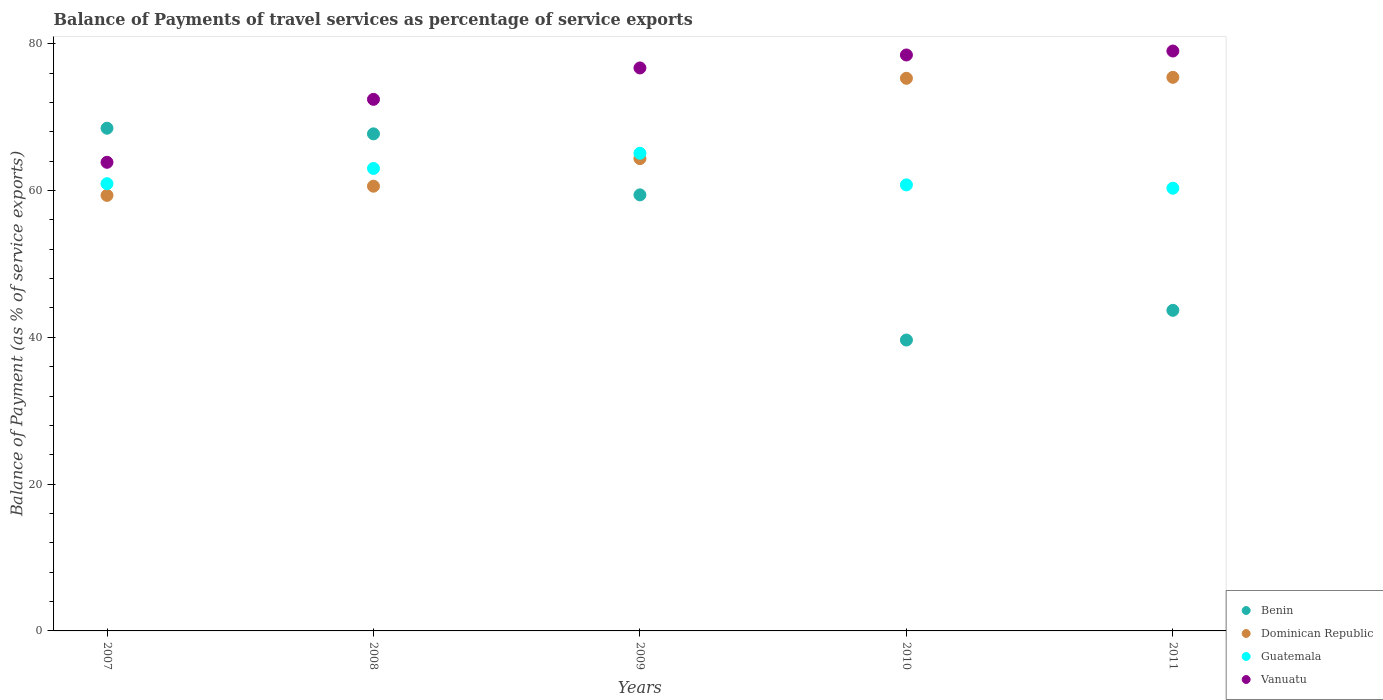How many different coloured dotlines are there?
Provide a succinct answer. 4. What is the balance of payments of travel services in Guatemala in 2007?
Offer a very short reply. 60.92. Across all years, what is the maximum balance of payments of travel services in Benin?
Provide a short and direct response. 68.48. Across all years, what is the minimum balance of payments of travel services in Benin?
Your response must be concise. 39.63. In which year was the balance of payments of travel services in Guatemala minimum?
Keep it short and to the point. 2011. What is the total balance of payments of travel services in Vanuatu in the graph?
Give a very brief answer. 370.39. What is the difference between the balance of payments of travel services in Vanuatu in 2008 and that in 2009?
Your response must be concise. -4.28. What is the difference between the balance of payments of travel services in Vanuatu in 2010 and the balance of payments of travel services in Dominican Republic in 2008?
Ensure brevity in your answer.  17.87. What is the average balance of payments of travel services in Dominican Republic per year?
Your answer should be very brief. 66.99. In the year 2011, what is the difference between the balance of payments of travel services in Benin and balance of payments of travel services in Dominican Republic?
Your response must be concise. -31.74. In how many years, is the balance of payments of travel services in Dominican Republic greater than 52 %?
Your answer should be compact. 5. What is the ratio of the balance of payments of travel services in Guatemala in 2007 to that in 2009?
Your answer should be very brief. 0.94. Is the balance of payments of travel services in Vanuatu in 2008 less than that in 2009?
Provide a succinct answer. Yes. What is the difference between the highest and the second highest balance of payments of travel services in Dominican Republic?
Your answer should be very brief. 0.13. What is the difference between the highest and the lowest balance of payments of travel services in Vanuatu?
Make the answer very short. 15.16. Is it the case that in every year, the sum of the balance of payments of travel services in Benin and balance of payments of travel services in Vanuatu  is greater than the balance of payments of travel services in Dominican Republic?
Ensure brevity in your answer.  Yes. How many dotlines are there?
Offer a very short reply. 4. How many years are there in the graph?
Keep it short and to the point. 5. Are the values on the major ticks of Y-axis written in scientific E-notation?
Keep it short and to the point. No. Does the graph contain any zero values?
Your answer should be very brief. No. Does the graph contain grids?
Offer a very short reply. No. How are the legend labels stacked?
Your response must be concise. Vertical. What is the title of the graph?
Offer a terse response. Balance of Payments of travel services as percentage of service exports. Does "Poland" appear as one of the legend labels in the graph?
Offer a terse response. No. What is the label or title of the Y-axis?
Your answer should be very brief. Balance of Payment (as % of service exports). What is the Balance of Payment (as % of service exports) in Benin in 2007?
Give a very brief answer. 68.48. What is the Balance of Payment (as % of service exports) of Dominican Republic in 2007?
Keep it short and to the point. 59.33. What is the Balance of Payment (as % of service exports) in Guatemala in 2007?
Your answer should be compact. 60.92. What is the Balance of Payment (as % of service exports) in Vanuatu in 2007?
Ensure brevity in your answer.  63.84. What is the Balance of Payment (as % of service exports) of Benin in 2008?
Provide a short and direct response. 67.71. What is the Balance of Payment (as % of service exports) in Dominican Republic in 2008?
Your response must be concise. 60.58. What is the Balance of Payment (as % of service exports) in Guatemala in 2008?
Keep it short and to the point. 63. What is the Balance of Payment (as % of service exports) of Vanuatu in 2008?
Your answer should be very brief. 72.41. What is the Balance of Payment (as % of service exports) in Benin in 2009?
Keep it short and to the point. 59.4. What is the Balance of Payment (as % of service exports) in Dominican Republic in 2009?
Your response must be concise. 64.34. What is the Balance of Payment (as % of service exports) in Guatemala in 2009?
Your answer should be compact. 65.07. What is the Balance of Payment (as % of service exports) in Vanuatu in 2009?
Offer a very short reply. 76.69. What is the Balance of Payment (as % of service exports) in Benin in 2010?
Give a very brief answer. 39.63. What is the Balance of Payment (as % of service exports) of Dominican Republic in 2010?
Offer a terse response. 75.28. What is the Balance of Payment (as % of service exports) of Guatemala in 2010?
Provide a short and direct response. 60.76. What is the Balance of Payment (as % of service exports) in Vanuatu in 2010?
Provide a succinct answer. 78.46. What is the Balance of Payment (as % of service exports) of Benin in 2011?
Offer a very short reply. 43.67. What is the Balance of Payment (as % of service exports) in Dominican Republic in 2011?
Ensure brevity in your answer.  75.41. What is the Balance of Payment (as % of service exports) of Guatemala in 2011?
Provide a succinct answer. 60.31. What is the Balance of Payment (as % of service exports) in Vanuatu in 2011?
Offer a very short reply. 78.99. Across all years, what is the maximum Balance of Payment (as % of service exports) of Benin?
Make the answer very short. 68.48. Across all years, what is the maximum Balance of Payment (as % of service exports) in Dominican Republic?
Give a very brief answer. 75.41. Across all years, what is the maximum Balance of Payment (as % of service exports) in Guatemala?
Provide a succinct answer. 65.07. Across all years, what is the maximum Balance of Payment (as % of service exports) of Vanuatu?
Offer a terse response. 78.99. Across all years, what is the minimum Balance of Payment (as % of service exports) in Benin?
Make the answer very short. 39.63. Across all years, what is the minimum Balance of Payment (as % of service exports) of Dominican Republic?
Your response must be concise. 59.33. Across all years, what is the minimum Balance of Payment (as % of service exports) in Guatemala?
Your response must be concise. 60.31. Across all years, what is the minimum Balance of Payment (as % of service exports) in Vanuatu?
Ensure brevity in your answer.  63.84. What is the total Balance of Payment (as % of service exports) of Benin in the graph?
Give a very brief answer. 278.89. What is the total Balance of Payment (as % of service exports) in Dominican Republic in the graph?
Offer a terse response. 334.94. What is the total Balance of Payment (as % of service exports) of Guatemala in the graph?
Keep it short and to the point. 310.06. What is the total Balance of Payment (as % of service exports) in Vanuatu in the graph?
Your answer should be compact. 370.39. What is the difference between the Balance of Payment (as % of service exports) of Benin in 2007 and that in 2008?
Ensure brevity in your answer.  0.77. What is the difference between the Balance of Payment (as % of service exports) of Dominican Republic in 2007 and that in 2008?
Make the answer very short. -1.25. What is the difference between the Balance of Payment (as % of service exports) in Guatemala in 2007 and that in 2008?
Provide a short and direct response. -2.08. What is the difference between the Balance of Payment (as % of service exports) of Vanuatu in 2007 and that in 2008?
Offer a very short reply. -8.58. What is the difference between the Balance of Payment (as % of service exports) of Benin in 2007 and that in 2009?
Provide a succinct answer. 9.08. What is the difference between the Balance of Payment (as % of service exports) in Dominican Republic in 2007 and that in 2009?
Your answer should be compact. -5.01. What is the difference between the Balance of Payment (as % of service exports) of Guatemala in 2007 and that in 2009?
Give a very brief answer. -4.14. What is the difference between the Balance of Payment (as % of service exports) of Vanuatu in 2007 and that in 2009?
Offer a terse response. -12.86. What is the difference between the Balance of Payment (as % of service exports) in Benin in 2007 and that in 2010?
Provide a succinct answer. 28.85. What is the difference between the Balance of Payment (as % of service exports) in Dominican Republic in 2007 and that in 2010?
Give a very brief answer. -15.95. What is the difference between the Balance of Payment (as % of service exports) of Guatemala in 2007 and that in 2010?
Provide a short and direct response. 0.16. What is the difference between the Balance of Payment (as % of service exports) of Vanuatu in 2007 and that in 2010?
Make the answer very short. -14.62. What is the difference between the Balance of Payment (as % of service exports) of Benin in 2007 and that in 2011?
Your response must be concise. 24.81. What is the difference between the Balance of Payment (as % of service exports) of Dominican Republic in 2007 and that in 2011?
Provide a succinct answer. -16.08. What is the difference between the Balance of Payment (as % of service exports) of Guatemala in 2007 and that in 2011?
Provide a short and direct response. 0.62. What is the difference between the Balance of Payment (as % of service exports) of Vanuatu in 2007 and that in 2011?
Keep it short and to the point. -15.16. What is the difference between the Balance of Payment (as % of service exports) in Benin in 2008 and that in 2009?
Keep it short and to the point. 8.31. What is the difference between the Balance of Payment (as % of service exports) of Dominican Republic in 2008 and that in 2009?
Keep it short and to the point. -3.76. What is the difference between the Balance of Payment (as % of service exports) of Guatemala in 2008 and that in 2009?
Your answer should be compact. -2.07. What is the difference between the Balance of Payment (as % of service exports) in Vanuatu in 2008 and that in 2009?
Offer a very short reply. -4.28. What is the difference between the Balance of Payment (as % of service exports) in Benin in 2008 and that in 2010?
Your response must be concise. 28.08. What is the difference between the Balance of Payment (as % of service exports) in Dominican Republic in 2008 and that in 2010?
Offer a very short reply. -14.7. What is the difference between the Balance of Payment (as % of service exports) of Guatemala in 2008 and that in 2010?
Your response must be concise. 2.24. What is the difference between the Balance of Payment (as % of service exports) of Vanuatu in 2008 and that in 2010?
Your answer should be very brief. -6.04. What is the difference between the Balance of Payment (as % of service exports) in Benin in 2008 and that in 2011?
Provide a short and direct response. 24.04. What is the difference between the Balance of Payment (as % of service exports) of Dominican Republic in 2008 and that in 2011?
Your answer should be very brief. -14.83. What is the difference between the Balance of Payment (as % of service exports) in Guatemala in 2008 and that in 2011?
Give a very brief answer. 2.69. What is the difference between the Balance of Payment (as % of service exports) in Vanuatu in 2008 and that in 2011?
Offer a terse response. -6.58. What is the difference between the Balance of Payment (as % of service exports) of Benin in 2009 and that in 2010?
Offer a terse response. 19.77. What is the difference between the Balance of Payment (as % of service exports) of Dominican Republic in 2009 and that in 2010?
Your answer should be compact. -10.94. What is the difference between the Balance of Payment (as % of service exports) in Guatemala in 2009 and that in 2010?
Keep it short and to the point. 4.31. What is the difference between the Balance of Payment (as % of service exports) of Vanuatu in 2009 and that in 2010?
Your response must be concise. -1.77. What is the difference between the Balance of Payment (as % of service exports) of Benin in 2009 and that in 2011?
Make the answer very short. 15.73. What is the difference between the Balance of Payment (as % of service exports) of Dominican Republic in 2009 and that in 2011?
Give a very brief answer. -11.07. What is the difference between the Balance of Payment (as % of service exports) in Guatemala in 2009 and that in 2011?
Your response must be concise. 4.76. What is the difference between the Balance of Payment (as % of service exports) in Vanuatu in 2009 and that in 2011?
Offer a very short reply. -2.3. What is the difference between the Balance of Payment (as % of service exports) of Benin in 2010 and that in 2011?
Keep it short and to the point. -4.04. What is the difference between the Balance of Payment (as % of service exports) in Dominican Republic in 2010 and that in 2011?
Provide a succinct answer. -0.13. What is the difference between the Balance of Payment (as % of service exports) of Guatemala in 2010 and that in 2011?
Your answer should be compact. 0.46. What is the difference between the Balance of Payment (as % of service exports) in Vanuatu in 2010 and that in 2011?
Offer a very short reply. -0.54. What is the difference between the Balance of Payment (as % of service exports) in Benin in 2007 and the Balance of Payment (as % of service exports) in Dominican Republic in 2008?
Provide a short and direct response. 7.9. What is the difference between the Balance of Payment (as % of service exports) of Benin in 2007 and the Balance of Payment (as % of service exports) of Guatemala in 2008?
Provide a short and direct response. 5.48. What is the difference between the Balance of Payment (as % of service exports) in Benin in 2007 and the Balance of Payment (as % of service exports) in Vanuatu in 2008?
Provide a succinct answer. -3.93. What is the difference between the Balance of Payment (as % of service exports) of Dominican Republic in 2007 and the Balance of Payment (as % of service exports) of Guatemala in 2008?
Your response must be concise. -3.67. What is the difference between the Balance of Payment (as % of service exports) in Dominican Republic in 2007 and the Balance of Payment (as % of service exports) in Vanuatu in 2008?
Offer a terse response. -13.08. What is the difference between the Balance of Payment (as % of service exports) in Guatemala in 2007 and the Balance of Payment (as % of service exports) in Vanuatu in 2008?
Keep it short and to the point. -11.49. What is the difference between the Balance of Payment (as % of service exports) of Benin in 2007 and the Balance of Payment (as % of service exports) of Dominican Republic in 2009?
Offer a very short reply. 4.14. What is the difference between the Balance of Payment (as % of service exports) in Benin in 2007 and the Balance of Payment (as % of service exports) in Guatemala in 2009?
Provide a short and direct response. 3.41. What is the difference between the Balance of Payment (as % of service exports) in Benin in 2007 and the Balance of Payment (as % of service exports) in Vanuatu in 2009?
Provide a succinct answer. -8.21. What is the difference between the Balance of Payment (as % of service exports) in Dominican Republic in 2007 and the Balance of Payment (as % of service exports) in Guatemala in 2009?
Provide a short and direct response. -5.74. What is the difference between the Balance of Payment (as % of service exports) in Dominican Republic in 2007 and the Balance of Payment (as % of service exports) in Vanuatu in 2009?
Provide a succinct answer. -17.36. What is the difference between the Balance of Payment (as % of service exports) in Guatemala in 2007 and the Balance of Payment (as % of service exports) in Vanuatu in 2009?
Make the answer very short. -15.77. What is the difference between the Balance of Payment (as % of service exports) of Benin in 2007 and the Balance of Payment (as % of service exports) of Dominican Republic in 2010?
Give a very brief answer. -6.8. What is the difference between the Balance of Payment (as % of service exports) of Benin in 2007 and the Balance of Payment (as % of service exports) of Guatemala in 2010?
Give a very brief answer. 7.72. What is the difference between the Balance of Payment (as % of service exports) of Benin in 2007 and the Balance of Payment (as % of service exports) of Vanuatu in 2010?
Offer a very short reply. -9.98. What is the difference between the Balance of Payment (as % of service exports) in Dominican Republic in 2007 and the Balance of Payment (as % of service exports) in Guatemala in 2010?
Your answer should be compact. -1.43. What is the difference between the Balance of Payment (as % of service exports) of Dominican Republic in 2007 and the Balance of Payment (as % of service exports) of Vanuatu in 2010?
Ensure brevity in your answer.  -19.13. What is the difference between the Balance of Payment (as % of service exports) of Guatemala in 2007 and the Balance of Payment (as % of service exports) of Vanuatu in 2010?
Ensure brevity in your answer.  -17.53. What is the difference between the Balance of Payment (as % of service exports) in Benin in 2007 and the Balance of Payment (as % of service exports) in Dominican Republic in 2011?
Your answer should be very brief. -6.93. What is the difference between the Balance of Payment (as % of service exports) of Benin in 2007 and the Balance of Payment (as % of service exports) of Guatemala in 2011?
Make the answer very short. 8.17. What is the difference between the Balance of Payment (as % of service exports) of Benin in 2007 and the Balance of Payment (as % of service exports) of Vanuatu in 2011?
Provide a short and direct response. -10.52. What is the difference between the Balance of Payment (as % of service exports) of Dominican Republic in 2007 and the Balance of Payment (as % of service exports) of Guatemala in 2011?
Provide a short and direct response. -0.98. What is the difference between the Balance of Payment (as % of service exports) in Dominican Republic in 2007 and the Balance of Payment (as % of service exports) in Vanuatu in 2011?
Your answer should be compact. -19.67. What is the difference between the Balance of Payment (as % of service exports) in Guatemala in 2007 and the Balance of Payment (as % of service exports) in Vanuatu in 2011?
Ensure brevity in your answer.  -18.07. What is the difference between the Balance of Payment (as % of service exports) of Benin in 2008 and the Balance of Payment (as % of service exports) of Dominican Republic in 2009?
Provide a succinct answer. 3.37. What is the difference between the Balance of Payment (as % of service exports) in Benin in 2008 and the Balance of Payment (as % of service exports) in Guatemala in 2009?
Your response must be concise. 2.64. What is the difference between the Balance of Payment (as % of service exports) of Benin in 2008 and the Balance of Payment (as % of service exports) of Vanuatu in 2009?
Make the answer very short. -8.98. What is the difference between the Balance of Payment (as % of service exports) of Dominican Republic in 2008 and the Balance of Payment (as % of service exports) of Guatemala in 2009?
Provide a succinct answer. -4.49. What is the difference between the Balance of Payment (as % of service exports) of Dominican Republic in 2008 and the Balance of Payment (as % of service exports) of Vanuatu in 2009?
Provide a short and direct response. -16.11. What is the difference between the Balance of Payment (as % of service exports) in Guatemala in 2008 and the Balance of Payment (as % of service exports) in Vanuatu in 2009?
Offer a very short reply. -13.69. What is the difference between the Balance of Payment (as % of service exports) in Benin in 2008 and the Balance of Payment (as % of service exports) in Dominican Republic in 2010?
Your answer should be compact. -7.57. What is the difference between the Balance of Payment (as % of service exports) of Benin in 2008 and the Balance of Payment (as % of service exports) of Guatemala in 2010?
Your answer should be very brief. 6.95. What is the difference between the Balance of Payment (as % of service exports) in Benin in 2008 and the Balance of Payment (as % of service exports) in Vanuatu in 2010?
Offer a terse response. -10.75. What is the difference between the Balance of Payment (as % of service exports) of Dominican Republic in 2008 and the Balance of Payment (as % of service exports) of Guatemala in 2010?
Provide a short and direct response. -0.18. What is the difference between the Balance of Payment (as % of service exports) in Dominican Republic in 2008 and the Balance of Payment (as % of service exports) in Vanuatu in 2010?
Your response must be concise. -17.87. What is the difference between the Balance of Payment (as % of service exports) of Guatemala in 2008 and the Balance of Payment (as % of service exports) of Vanuatu in 2010?
Offer a terse response. -15.46. What is the difference between the Balance of Payment (as % of service exports) in Benin in 2008 and the Balance of Payment (as % of service exports) in Dominican Republic in 2011?
Provide a succinct answer. -7.7. What is the difference between the Balance of Payment (as % of service exports) in Benin in 2008 and the Balance of Payment (as % of service exports) in Guatemala in 2011?
Your response must be concise. 7.41. What is the difference between the Balance of Payment (as % of service exports) in Benin in 2008 and the Balance of Payment (as % of service exports) in Vanuatu in 2011?
Keep it short and to the point. -11.28. What is the difference between the Balance of Payment (as % of service exports) of Dominican Republic in 2008 and the Balance of Payment (as % of service exports) of Guatemala in 2011?
Give a very brief answer. 0.28. What is the difference between the Balance of Payment (as % of service exports) of Dominican Republic in 2008 and the Balance of Payment (as % of service exports) of Vanuatu in 2011?
Your answer should be compact. -18.41. What is the difference between the Balance of Payment (as % of service exports) of Guatemala in 2008 and the Balance of Payment (as % of service exports) of Vanuatu in 2011?
Ensure brevity in your answer.  -15.99. What is the difference between the Balance of Payment (as % of service exports) in Benin in 2009 and the Balance of Payment (as % of service exports) in Dominican Republic in 2010?
Your answer should be very brief. -15.88. What is the difference between the Balance of Payment (as % of service exports) in Benin in 2009 and the Balance of Payment (as % of service exports) in Guatemala in 2010?
Offer a very short reply. -1.36. What is the difference between the Balance of Payment (as % of service exports) in Benin in 2009 and the Balance of Payment (as % of service exports) in Vanuatu in 2010?
Give a very brief answer. -19.06. What is the difference between the Balance of Payment (as % of service exports) in Dominican Republic in 2009 and the Balance of Payment (as % of service exports) in Guatemala in 2010?
Ensure brevity in your answer.  3.58. What is the difference between the Balance of Payment (as % of service exports) of Dominican Republic in 2009 and the Balance of Payment (as % of service exports) of Vanuatu in 2010?
Offer a terse response. -14.12. What is the difference between the Balance of Payment (as % of service exports) in Guatemala in 2009 and the Balance of Payment (as % of service exports) in Vanuatu in 2010?
Your answer should be compact. -13.39. What is the difference between the Balance of Payment (as % of service exports) of Benin in 2009 and the Balance of Payment (as % of service exports) of Dominican Republic in 2011?
Offer a terse response. -16.01. What is the difference between the Balance of Payment (as % of service exports) of Benin in 2009 and the Balance of Payment (as % of service exports) of Guatemala in 2011?
Offer a terse response. -0.91. What is the difference between the Balance of Payment (as % of service exports) of Benin in 2009 and the Balance of Payment (as % of service exports) of Vanuatu in 2011?
Ensure brevity in your answer.  -19.59. What is the difference between the Balance of Payment (as % of service exports) of Dominican Republic in 2009 and the Balance of Payment (as % of service exports) of Guatemala in 2011?
Make the answer very short. 4.04. What is the difference between the Balance of Payment (as % of service exports) in Dominican Republic in 2009 and the Balance of Payment (as % of service exports) in Vanuatu in 2011?
Give a very brief answer. -14.65. What is the difference between the Balance of Payment (as % of service exports) in Guatemala in 2009 and the Balance of Payment (as % of service exports) in Vanuatu in 2011?
Keep it short and to the point. -13.93. What is the difference between the Balance of Payment (as % of service exports) in Benin in 2010 and the Balance of Payment (as % of service exports) in Dominican Republic in 2011?
Give a very brief answer. -35.78. What is the difference between the Balance of Payment (as % of service exports) in Benin in 2010 and the Balance of Payment (as % of service exports) in Guatemala in 2011?
Offer a very short reply. -20.68. What is the difference between the Balance of Payment (as % of service exports) of Benin in 2010 and the Balance of Payment (as % of service exports) of Vanuatu in 2011?
Ensure brevity in your answer.  -39.37. What is the difference between the Balance of Payment (as % of service exports) of Dominican Republic in 2010 and the Balance of Payment (as % of service exports) of Guatemala in 2011?
Make the answer very short. 14.98. What is the difference between the Balance of Payment (as % of service exports) of Dominican Republic in 2010 and the Balance of Payment (as % of service exports) of Vanuatu in 2011?
Ensure brevity in your answer.  -3.71. What is the difference between the Balance of Payment (as % of service exports) of Guatemala in 2010 and the Balance of Payment (as % of service exports) of Vanuatu in 2011?
Provide a succinct answer. -18.23. What is the average Balance of Payment (as % of service exports) of Benin per year?
Make the answer very short. 55.78. What is the average Balance of Payment (as % of service exports) of Dominican Republic per year?
Offer a very short reply. 66.99. What is the average Balance of Payment (as % of service exports) of Guatemala per year?
Make the answer very short. 62.01. What is the average Balance of Payment (as % of service exports) of Vanuatu per year?
Keep it short and to the point. 74.08. In the year 2007, what is the difference between the Balance of Payment (as % of service exports) of Benin and Balance of Payment (as % of service exports) of Dominican Republic?
Offer a very short reply. 9.15. In the year 2007, what is the difference between the Balance of Payment (as % of service exports) of Benin and Balance of Payment (as % of service exports) of Guatemala?
Your answer should be compact. 7.56. In the year 2007, what is the difference between the Balance of Payment (as % of service exports) of Benin and Balance of Payment (as % of service exports) of Vanuatu?
Your answer should be compact. 4.64. In the year 2007, what is the difference between the Balance of Payment (as % of service exports) in Dominican Republic and Balance of Payment (as % of service exports) in Guatemala?
Your answer should be very brief. -1.59. In the year 2007, what is the difference between the Balance of Payment (as % of service exports) of Dominican Republic and Balance of Payment (as % of service exports) of Vanuatu?
Offer a very short reply. -4.51. In the year 2007, what is the difference between the Balance of Payment (as % of service exports) in Guatemala and Balance of Payment (as % of service exports) in Vanuatu?
Make the answer very short. -2.91. In the year 2008, what is the difference between the Balance of Payment (as % of service exports) in Benin and Balance of Payment (as % of service exports) in Dominican Republic?
Make the answer very short. 7.13. In the year 2008, what is the difference between the Balance of Payment (as % of service exports) in Benin and Balance of Payment (as % of service exports) in Guatemala?
Offer a very short reply. 4.71. In the year 2008, what is the difference between the Balance of Payment (as % of service exports) of Benin and Balance of Payment (as % of service exports) of Vanuatu?
Give a very brief answer. -4.7. In the year 2008, what is the difference between the Balance of Payment (as % of service exports) of Dominican Republic and Balance of Payment (as % of service exports) of Guatemala?
Offer a very short reply. -2.42. In the year 2008, what is the difference between the Balance of Payment (as % of service exports) of Dominican Republic and Balance of Payment (as % of service exports) of Vanuatu?
Offer a terse response. -11.83. In the year 2008, what is the difference between the Balance of Payment (as % of service exports) in Guatemala and Balance of Payment (as % of service exports) in Vanuatu?
Offer a terse response. -9.41. In the year 2009, what is the difference between the Balance of Payment (as % of service exports) in Benin and Balance of Payment (as % of service exports) in Dominican Republic?
Provide a short and direct response. -4.94. In the year 2009, what is the difference between the Balance of Payment (as % of service exports) of Benin and Balance of Payment (as % of service exports) of Guatemala?
Offer a terse response. -5.67. In the year 2009, what is the difference between the Balance of Payment (as % of service exports) of Benin and Balance of Payment (as % of service exports) of Vanuatu?
Offer a very short reply. -17.29. In the year 2009, what is the difference between the Balance of Payment (as % of service exports) in Dominican Republic and Balance of Payment (as % of service exports) in Guatemala?
Make the answer very short. -0.73. In the year 2009, what is the difference between the Balance of Payment (as % of service exports) in Dominican Republic and Balance of Payment (as % of service exports) in Vanuatu?
Your response must be concise. -12.35. In the year 2009, what is the difference between the Balance of Payment (as % of service exports) in Guatemala and Balance of Payment (as % of service exports) in Vanuatu?
Provide a succinct answer. -11.62. In the year 2010, what is the difference between the Balance of Payment (as % of service exports) of Benin and Balance of Payment (as % of service exports) of Dominican Republic?
Provide a short and direct response. -35.65. In the year 2010, what is the difference between the Balance of Payment (as % of service exports) in Benin and Balance of Payment (as % of service exports) in Guatemala?
Give a very brief answer. -21.13. In the year 2010, what is the difference between the Balance of Payment (as % of service exports) of Benin and Balance of Payment (as % of service exports) of Vanuatu?
Make the answer very short. -38.83. In the year 2010, what is the difference between the Balance of Payment (as % of service exports) in Dominican Republic and Balance of Payment (as % of service exports) in Guatemala?
Ensure brevity in your answer.  14.52. In the year 2010, what is the difference between the Balance of Payment (as % of service exports) in Dominican Republic and Balance of Payment (as % of service exports) in Vanuatu?
Offer a very short reply. -3.18. In the year 2010, what is the difference between the Balance of Payment (as % of service exports) in Guatemala and Balance of Payment (as % of service exports) in Vanuatu?
Your answer should be compact. -17.7. In the year 2011, what is the difference between the Balance of Payment (as % of service exports) in Benin and Balance of Payment (as % of service exports) in Dominican Republic?
Keep it short and to the point. -31.74. In the year 2011, what is the difference between the Balance of Payment (as % of service exports) in Benin and Balance of Payment (as % of service exports) in Guatemala?
Provide a short and direct response. -16.63. In the year 2011, what is the difference between the Balance of Payment (as % of service exports) of Benin and Balance of Payment (as % of service exports) of Vanuatu?
Your answer should be very brief. -35.32. In the year 2011, what is the difference between the Balance of Payment (as % of service exports) in Dominican Republic and Balance of Payment (as % of service exports) in Guatemala?
Provide a succinct answer. 15.11. In the year 2011, what is the difference between the Balance of Payment (as % of service exports) of Dominican Republic and Balance of Payment (as % of service exports) of Vanuatu?
Make the answer very short. -3.58. In the year 2011, what is the difference between the Balance of Payment (as % of service exports) in Guatemala and Balance of Payment (as % of service exports) in Vanuatu?
Give a very brief answer. -18.69. What is the ratio of the Balance of Payment (as % of service exports) of Benin in 2007 to that in 2008?
Your answer should be compact. 1.01. What is the ratio of the Balance of Payment (as % of service exports) in Dominican Republic in 2007 to that in 2008?
Your answer should be very brief. 0.98. What is the ratio of the Balance of Payment (as % of service exports) in Vanuatu in 2007 to that in 2008?
Your answer should be compact. 0.88. What is the ratio of the Balance of Payment (as % of service exports) in Benin in 2007 to that in 2009?
Keep it short and to the point. 1.15. What is the ratio of the Balance of Payment (as % of service exports) of Dominican Republic in 2007 to that in 2009?
Make the answer very short. 0.92. What is the ratio of the Balance of Payment (as % of service exports) of Guatemala in 2007 to that in 2009?
Your answer should be very brief. 0.94. What is the ratio of the Balance of Payment (as % of service exports) in Vanuatu in 2007 to that in 2009?
Ensure brevity in your answer.  0.83. What is the ratio of the Balance of Payment (as % of service exports) in Benin in 2007 to that in 2010?
Your answer should be compact. 1.73. What is the ratio of the Balance of Payment (as % of service exports) in Dominican Republic in 2007 to that in 2010?
Offer a very short reply. 0.79. What is the ratio of the Balance of Payment (as % of service exports) in Guatemala in 2007 to that in 2010?
Make the answer very short. 1. What is the ratio of the Balance of Payment (as % of service exports) of Vanuatu in 2007 to that in 2010?
Provide a succinct answer. 0.81. What is the ratio of the Balance of Payment (as % of service exports) in Benin in 2007 to that in 2011?
Give a very brief answer. 1.57. What is the ratio of the Balance of Payment (as % of service exports) of Dominican Republic in 2007 to that in 2011?
Ensure brevity in your answer.  0.79. What is the ratio of the Balance of Payment (as % of service exports) in Guatemala in 2007 to that in 2011?
Provide a short and direct response. 1.01. What is the ratio of the Balance of Payment (as % of service exports) of Vanuatu in 2007 to that in 2011?
Provide a succinct answer. 0.81. What is the ratio of the Balance of Payment (as % of service exports) of Benin in 2008 to that in 2009?
Make the answer very short. 1.14. What is the ratio of the Balance of Payment (as % of service exports) of Dominican Republic in 2008 to that in 2009?
Ensure brevity in your answer.  0.94. What is the ratio of the Balance of Payment (as % of service exports) of Guatemala in 2008 to that in 2009?
Your answer should be very brief. 0.97. What is the ratio of the Balance of Payment (as % of service exports) in Vanuatu in 2008 to that in 2009?
Ensure brevity in your answer.  0.94. What is the ratio of the Balance of Payment (as % of service exports) of Benin in 2008 to that in 2010?
Give a very brief answer. 1.71. What is the ratio of the Balance of Payment (as % of service exports) in Dominican Republic in 2008 to that in 2010?
Offer a very short reply. 0.8. What is the ratio of the Balance of Payment (as % of service exports) in Guatemala in 2008 to that in 2010?
Your answer should be compact. 1.04. What is the ratio of the Balance of Payment (as % of service exports) of Vanuatu in 2008 to that in 2010?
Give a very brief answer. 0.92. What is the ratio of the Balance of Payment (as % of service exports) of Benin in 2008 to that in 2011?
Make the answer very short. 1.55. What is the ratio of the Balance of Payment (as % of service exports) of Dominican Republic in 2008 to that in 2011?
Make the answer very short. 0.8. What is the ratio of the Balance of Payment (as % of service exports) of Guatemala in 2008 to that in 2011?
Keep it short and to the point. 1.04. What is the ratio of the Balance of Payment (as % of service exports) of Benin in 2009 to that in 2010?
Provide a short and direct response. 1.5. What is the ratio of the Balance of Payment (as % of service exports) of Dominican Republic in 2009 to that in 2010?
Make the answer very short. 0.85. What is the ratio of the Balance of Payment (as % of service exports) of Guatemala in 2009 to that in 2010?
Give a very brief answer. 1.07. What is the ratio of the Balance of Payment (as % of service exports) in Vanuatu in 2009 to that in 2010?
Ensure brevity in your answer.  0.98. What is the ratio of the Balance of Payment (as % of service exports) of Benin in 2009 to that in 2011?
Make the answer very short. 1.36. What is the ratio of the Balance of Payment (as % of service exports) in Dominican Republic in 2009 to that in 2011?
Ensure brevity in your answer.  0.85. What is the ratio of the Balance of Payment (as % of service exports) of Guatemala in 2009 to that in 2011?
Keep it short and to the point. 1.08. What is the ratio of the Balance of Payment (as % of service exports) of Vanuatu in 2009 to that in 2011?
Your answer should be very brief. 0.97. What is the ratio of the Balance of Payment (as % of service exports) of Benin in 2010 to that in 2011?
Your answer should be very brief. 0.91. What is the ratio of the Balance of Payment (as % of service exports) of Guatemala in 2010 to that in 2011?
Ensure brevity in your answer.  1.01. What is the ratio of the Balance of Payment (as % of service exports) in Vanuatu in 2010 to that in 2011?
Ensure brevity in your answer.  0.99. What is the difference between the highest and the second highest Balance of Payment (as % of service exports) of Benin?
Your response must be concise. 0.77. What is the difference between the highest and the second highest Balance of Payment (as % of service exports) in Dominican Republic?
Provide a short and direct response. 0.13. What is the difference between the highest and the second highest Balance of Payment (as % of service exports) in Guatemala?
Your answer should be very brief. 2.07. What is the difference between the highest and the second highest Balance of Payment (as % of service exports) in Vanuatu?
Make the answer very short. 0.54. What is the difference between the highest and the lowest Balance of Payment (as % of service exports) in Benin?
Your answer should be compact. 28.85. What is the difference between the highest and the lowest Balance of Payment (as % of service exports) in Dominican Republic?
Keep it short and to the point. 16.08. What is the difference between the highest and the lowest Balance of Payment (as % of service exports) in Guatemala?
Provide a short and direct response. 4.76. What is the difference between the highest and the lowest Balance of Payment (as % of service exports) in Vanuatu?
Offer a very short reply. 15.16. 